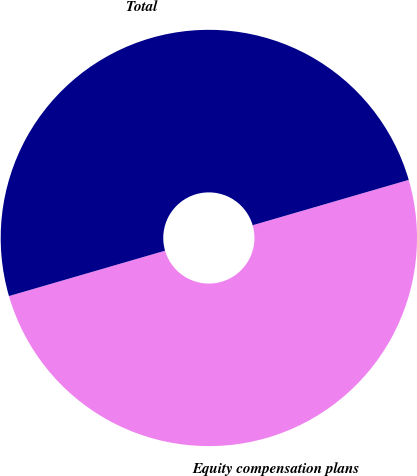<chart> <loc_0><loc_0><loc_500><loc_500><pie_chart><fcel>Equity compensation plans<fcel>Total<nl><fcel>50.0%<fcel>50.0%<nl></chart> 